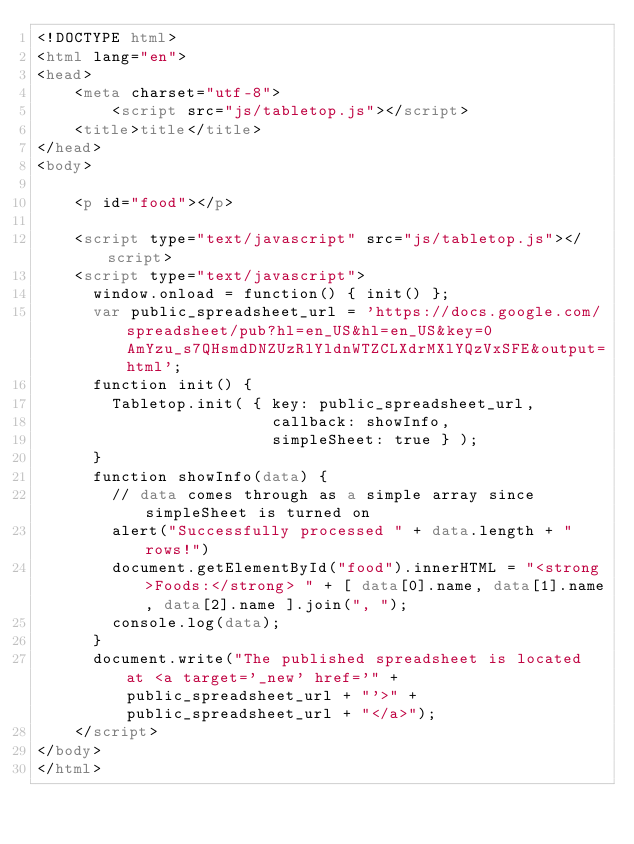Convert code to text. <code><loc_0><loc_0><loc_500><loc_500><_HTML_><!DOCTYPE html>
<html lang="en">
<head>
	<meta charset="utf-8">
		<script	src="js/tabletop.js"></script>
	<title>title</title>
</head>
<body>

    <p id="food"></p>

    <script type="text/javascript" src="js/tabletop.js"></script>
    <script type="text/javascript">
      window.onload = function() { init() };
      var public_spreadsheet_url = 'https://docs.google.com/spreadsheet/pub?hl=en_US&hl=en_US&key=0AmYzu_s7QHsmdDNZUzRlYldnWTZCLXdrMXlYQzVxSFE&output=html';
      function init() {
        Tabletop.init( { key: public_spreadsheet_url,
                         callback: showInfo,
                         simpleSheet: true } );
      }
      function showInfo(data) {
        // data comes through as a simple array since simpleSheet is turned on
        alert("Successfully processed " + data.length + " rows!")
        document.getElementById("food").innerHTML = "<strong>Foods:</strong> " + [ data[0].name, data[1].name, data[2].name ].join(", ");
        console.log(data);
      }
      document.write("The published spreadsheet is located at <a target='_new' href='" + public_spreadsheet_url + "'>" + public_spreadsheet_url + "</a>");        
    </script>
</body>
</html></code> 